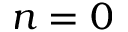Convert formula to latex. <formula><loc_0><loc_0><loc_500><loc_500>n = 0</formula> 